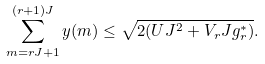Convert formula to latex. <formula><loc_0><loc_0><loc_500><loc_500>\sum _ { m = r J + 1 } ^ { ( r + 1 ) J } y ( m ) \leq \sqrt { 2 ( U J ^ { 2 } + V _ { r } J g ^ { * } _ { r } ) } .</formula> 